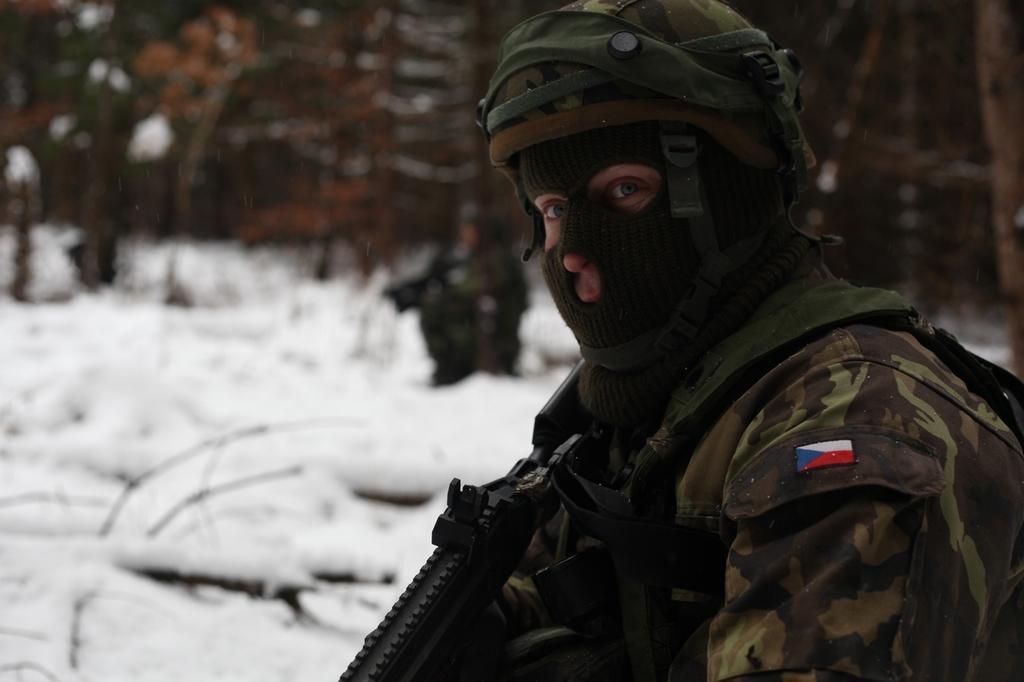Describe this image in one or two sentences. In the picture we can see an army man standing and holding a gun, he is with uniform and cap and full mask to his face and behind him we can see a snow surface and a man standing far near the trees which are not clearly visible. 